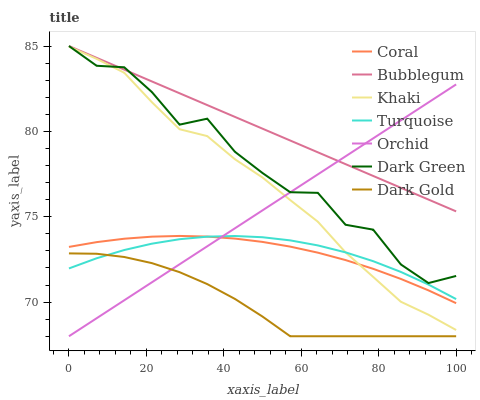Does Khaki have the minimum area under the curve?
Answer yes or no. No. Does Khaki have the maximum area under the curve?
Answer yes or no. No. Is Khaki the smoothest?
Answer yes or no. No. Is Khaki the roughest?
Answer yes or no. No. Does Khaki have the lowest value?
Answer yes or no. No. Does Khaki have the highest value?
Answer yes or no. No. Is Dark Gold less than Dark Green?
Answer yes or no. Yes. Is Khaki greater than Dark Gold?
Answer yes or no. Yes. Does Dark Gold intersect Dark Green?
Answer yes or no. No. 